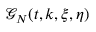Convert formula to latex. <formula><loc_0><loc_0><loc_500><loc_500>\mathcal { G } _ { N } ( t , k , \xi , \eta )</formula> 